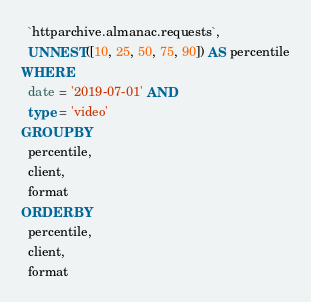Convert code to text. <code><loc_0><loc_0><loc_500><loc_500><_SQL_>  `httparchive.almanac.requests`,
  UNNEST([10, 25, 50, 75, 90]) AS percentile
WHERE
  date = '2019-07-01' AND
  type = 'video'
GROUP BY
  percentile,
  client,
  format
ORDER BY
  percentile,
  client,
  format
</code> 